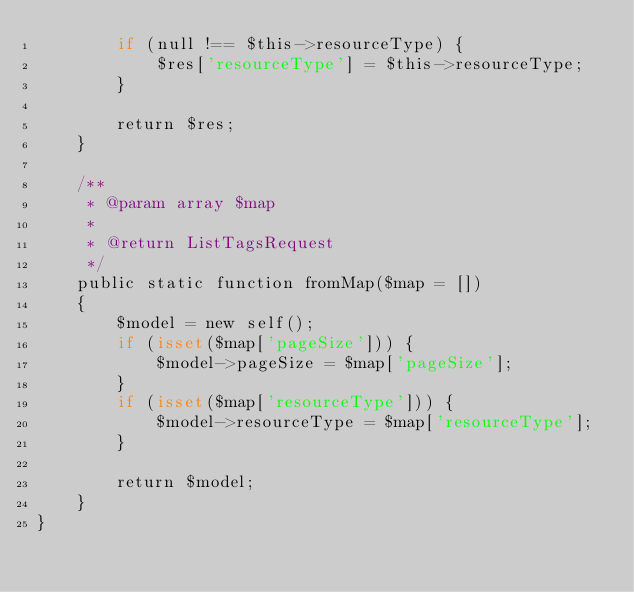<code> <loc_0><loc_0><loc_500><loc_500><_PHP_>        if (null !== $this->resourceType) {
            $res['resourceType'] = $this->resourceType;
        }

        return $res;
    }

    /**
     * @param array $map
     *
     * @return ListTagsRequest
     */
    public static function fromMap($map = [])
    {
        $model = new self();
        if (isset($map['pageSize'])) {
            $model->pageSize = $map['pageSize'];
        }
        if (isset($map['resourceType'])) {
            $model->resourceType = $map['resourceType'];
        }

        return $model;
    }
}
</code> 